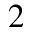Convert formula to latex. <formula><loc_0><loc_0><loc_500><loc_500>^ { 2 }</formula> 